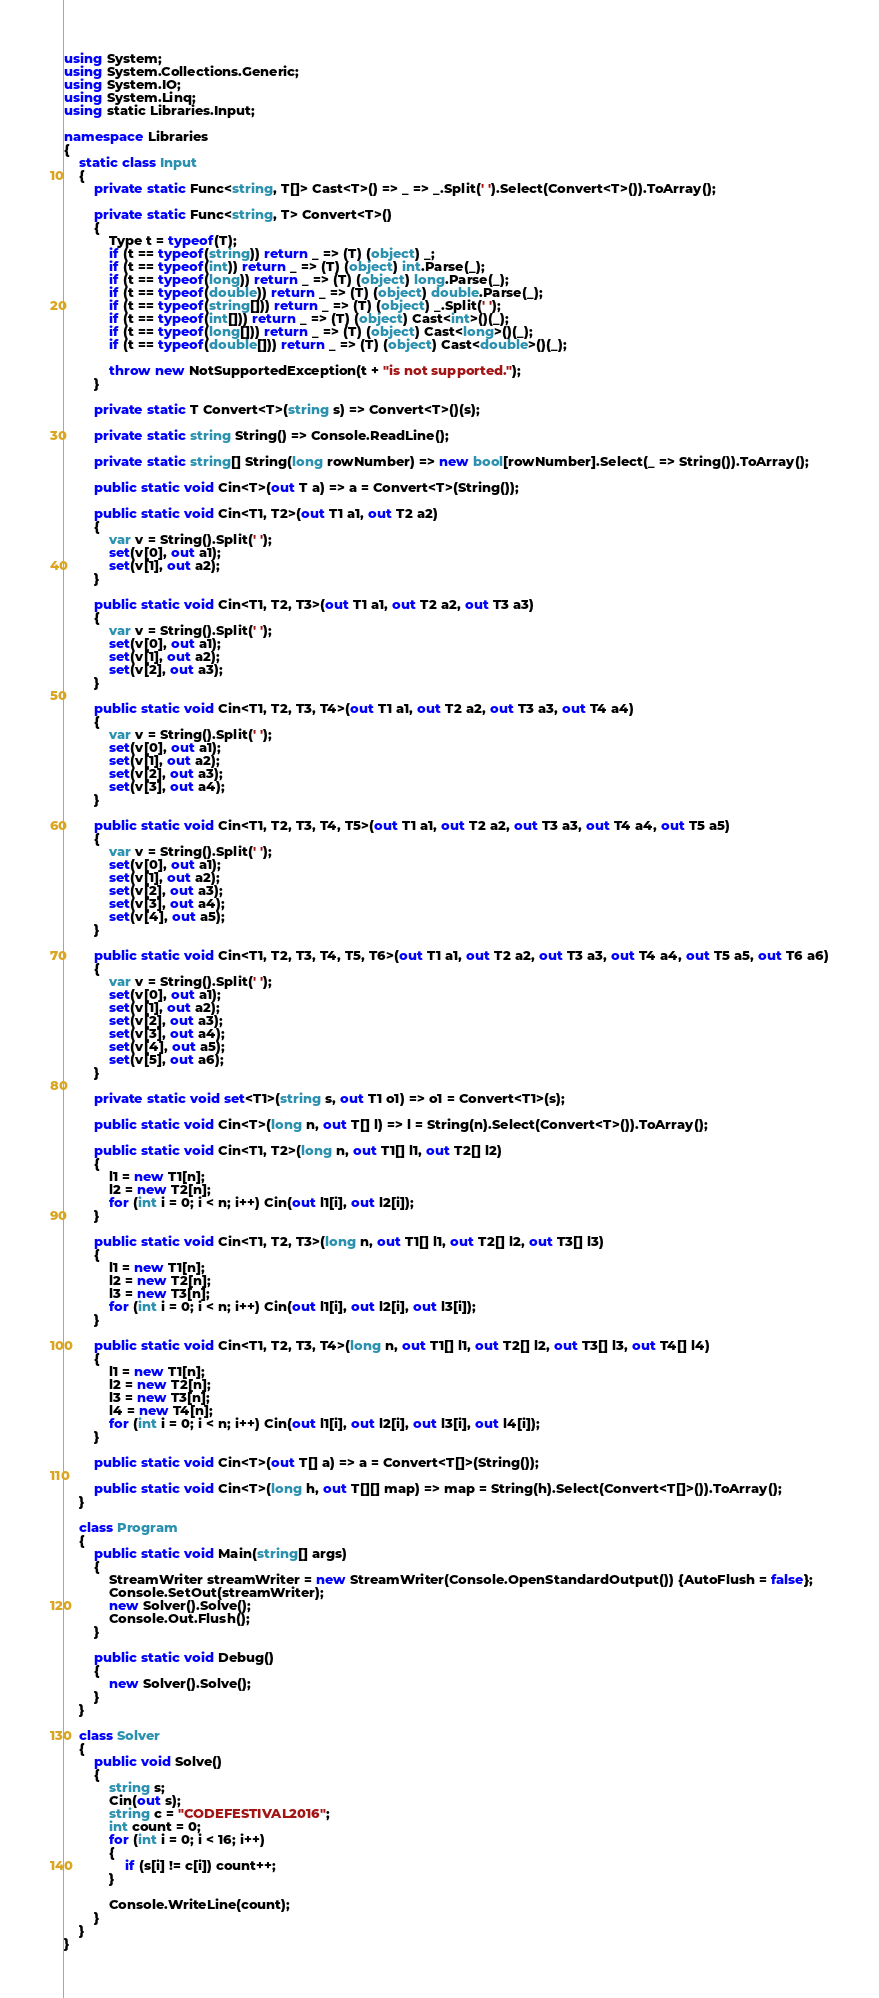Convert code to text. <code><loc_0><loc_0><loc_500><loc_500><_C#_>using System;
using System.Collections.Generic;
using System.IO;
using System.Linq;
using static Libraries.Input;

namespace Libraries
{
    static class Input
    {
        private static Func<string, T[]> Cast<T>() => _ => _.Split(' ').Select(Convert<T>()).ToArray();

        private static Func<string, T> Convert<T>()
        {
            Type t = typeof(T);
            if (t == typeof(string)) return _ => (T) (object) _;
            if (t == typeof(int)) return _ => (T) (object) int.Parse(_);
            if (t == typeof(long)) return _ => (T) (object) long.Parse(_);
            if (t == typeof(double)) return _ => (T) (object) double.Parse(_);
            if (t == typeof(string[])) return _ => (T) (object) _.Split(' ');
            if (t == typeof(int[])) return _ => (T) (object) Cast<int>()(_);
            if (t == typeof(long[])) return _ => (T) (object) Cast<long>()(_);
            if (t == typeof(double[])) return _ => (T) (object) Cast<double>()(_);

            throw new NotSupportedException(t + "is not supported.");
        }

        private static T Convert<T>(string s) => Convert<T>()(s);

        private static string String() => Console.ReadLine();

        private static string[] String(long rowNumber) => new bool[rowNumber].Select(_ => String()).ToArray();

        public static void Cin<T>(out T a) => a = Convert<T>(String());

        public static void Cin<T1, T2>(out T1 a1, out T2 a2)
        {
            var v = String().Split(' ');
            set(v[0], out a1);
            set(v[1], out a2);
        }

        public static void Cin<T1, T2, T3>(out T1 a1, out T2 a2, out T3 a3)
        {
            var v = String().Split(' ');
            set(v[0], out a1);
            set(v[1], out a2);
            set(v[2], out a3);
        }

        public static void Cin<T1, T2, T3, T4>(out T1 a1, out T2 a2, out T3 a3, out T4 a4)
        {
            var v = String().Split(' ');
            set(v[0], out a1);
            set(v[1], out a2);
            set(v[2], out a3);
            set(v[3], out a4);
        }

        public static void Cin<T1, T2, T3, T4, T5>(out T1 a1, out T2 a2, out T3 a3, out T4 a4, out T5 a5)
        {
            var v = String().Split(' ');
            set(v[0], out a1);
            set(v[1], out a2);
            set(v[2], out a3);
            set(v[3], out a4);
            set(v[4], out a5);
        }

        public static void Cin<T1, T2, T3, T4, T5, T6>(out T1 a1, out T2 a2, out T3 a3, out T4 a4, out T5 a5, out T6 a6)
        {
            var v = String().Split(' ');
            set(v[0], out a1);
            set(v[1], out a2);
            set(v[2], out a3);
            set(v[3], out a4);
            set(v[4], out a5);
            set(v[5], out a6);
        }

        private static void set<T1>(string s, out T1 o1) => o1 = Convert<T1>(s);

        public static void Cin<T>(long n, out T[] l) => l = String(n).Select(Convert<T>()).ToArray();

        public static void Cin<T1, T2>(long n, out T1[] l1, out T2[] l2)
        {
            l1 = new T1[n];
            l2 = new T2[n];
            for (int i = 0; i < n; i++) Cin(out l1[i], out l2[i]);
        }

        public static void Cin<T1, T2, T3>(long n, out T1[] l1, out T2[] l2, out T3[] l3)
        {
            l1 = new T1[n];
            l2 = new T2[n];
            l3 = new T3[n];
            for (int i = 0; i < n; i++) Cin(out l1[i], out l2[i], out l3[i]);
        }

        public static void Cin<T1, T2, T3, T4>(long n, out T1[] l1, out T2[] l2, out T3[] l3, out T4[] l4)
        {
            l1 = new T1[n];
            l2 = new T2[n];
            l3 = new T3[n];
            l4 = new T4[n];
            for (int i = 0; i < n; i++) Cin(out l1[i], out l2[i], out l3[i], out l4[i]);
        }

        public static void Cin<T>(out T[] a) => a = Convert<T[]>(String());

        public static void Cin<T>(long h, out T[][] map) => map = String(h).Select(Convert<T[]>()).ToArray();
    }

    class Program
    {
        public static void Main(string[] args)
        {
            StreamWriter streamWriter = new StreamWriter(Console.OpenStandardOutput()) {AutoFlush = false};
            Console.SetOut(streamWriter);
            new Solver().Solve();
            Console.Out.Flush();
        }

        public static void Debug()
        {
            new Solver().Solve();
        }
    }

    class Solver
    {
        public void Solve()
        {
            string s;
            Cin(out s);
            string c = "CODEFESTIVAL2016";
            int count = 0;
            for (int i = 0; i < 16; i++)
            {
                if (s[i] != c[i]) count++;
            }

            Console.WriteLine(count);
        }
    }
}</code> 